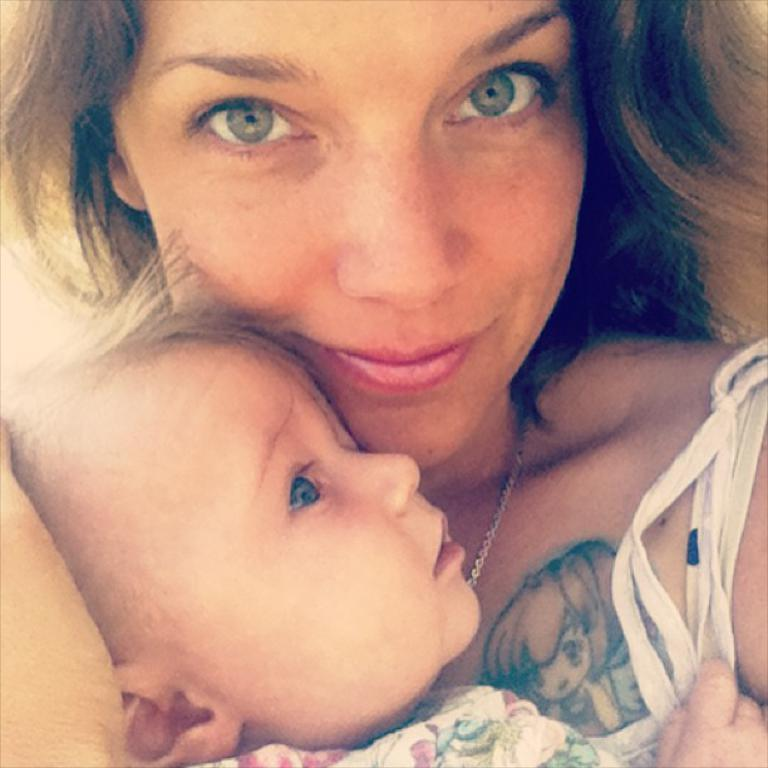Who is the main subject in the image? There is a woman in the image. What is the woman doing in the image? The woman is carrying a baby. What type of tools is the carpenter using to build the toy in the image? There is no carpenter or toy present in the image; it only features a woman carrying a baby. 